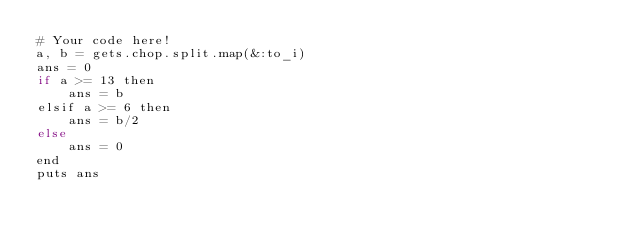<code> <loc_0><loc_0><loc_500><loc_500><_Kotlin_># Your code here!
a, b = gets.chop.split.map(&:to_i)
ans = 0
if a >= 13 then
    ans = b
elsif a >= 6 then
    ans = b/2
else
    ans = 0
end
puts ans</code> 